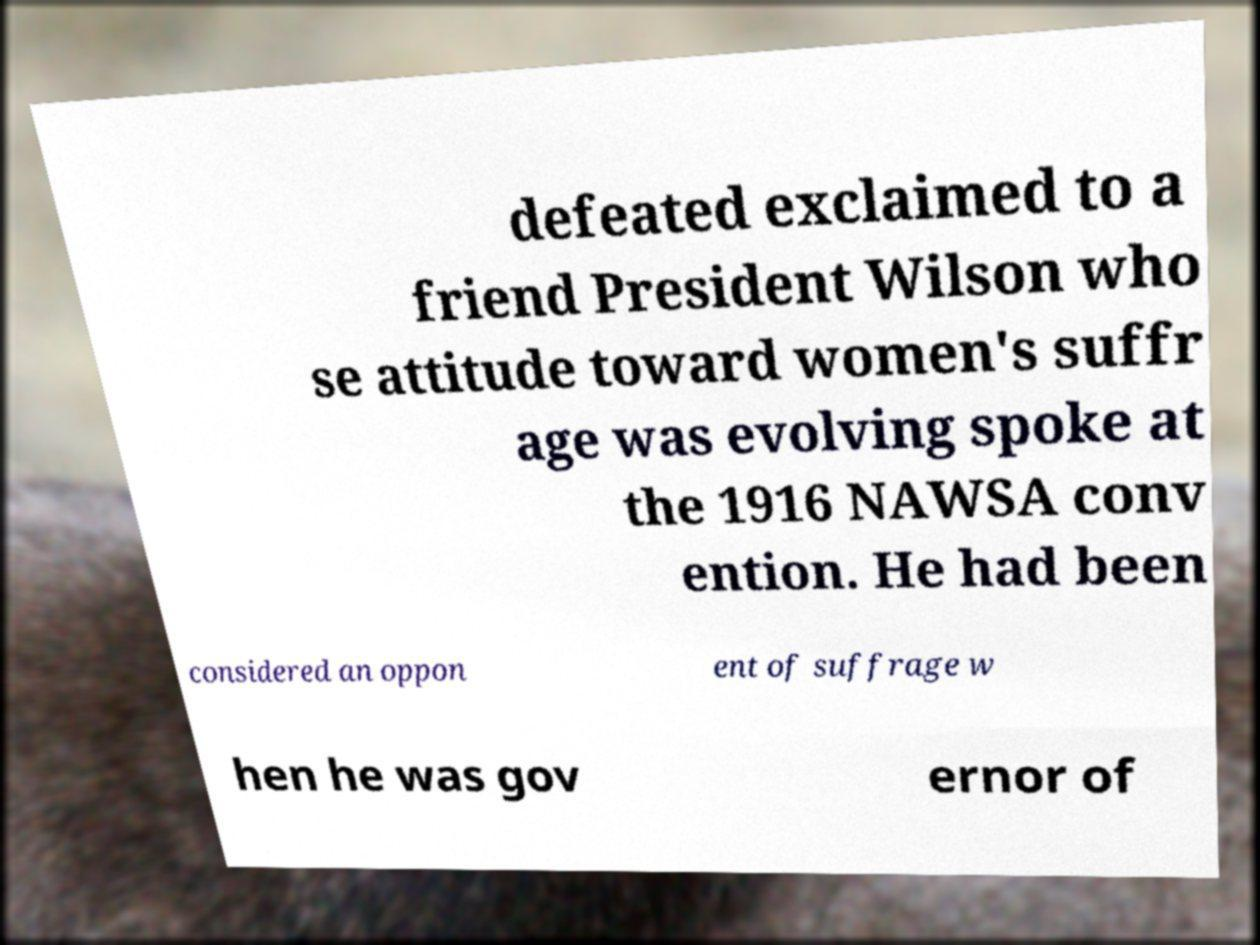What messages or text are displayed in this image? I need them in a readable, typed format. defeated exclaimed to a friend President Wilson who se attitude toward women's suffr age was evolving spoke at the 1916 NAWSA conv ention. He had been considered an oppon ent of suffrage w hen he was gov ernor of 